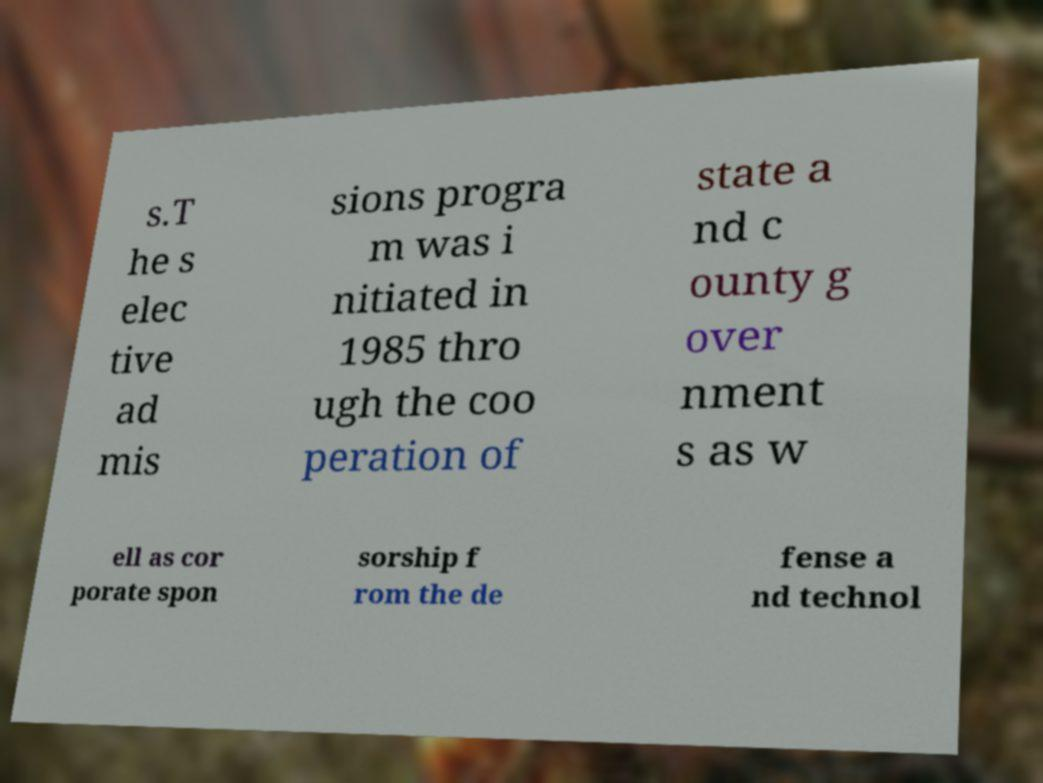For documentation purposes, I need the text within this image transcribed. Could you provide that? s.T he s elec tive ad mis sions progra m was i nitiated in 1985 thro ugh the coo peration of state a nd c ounty g over nment s as w ell as cor porate spon sorship f rom the de fense a nd technol 